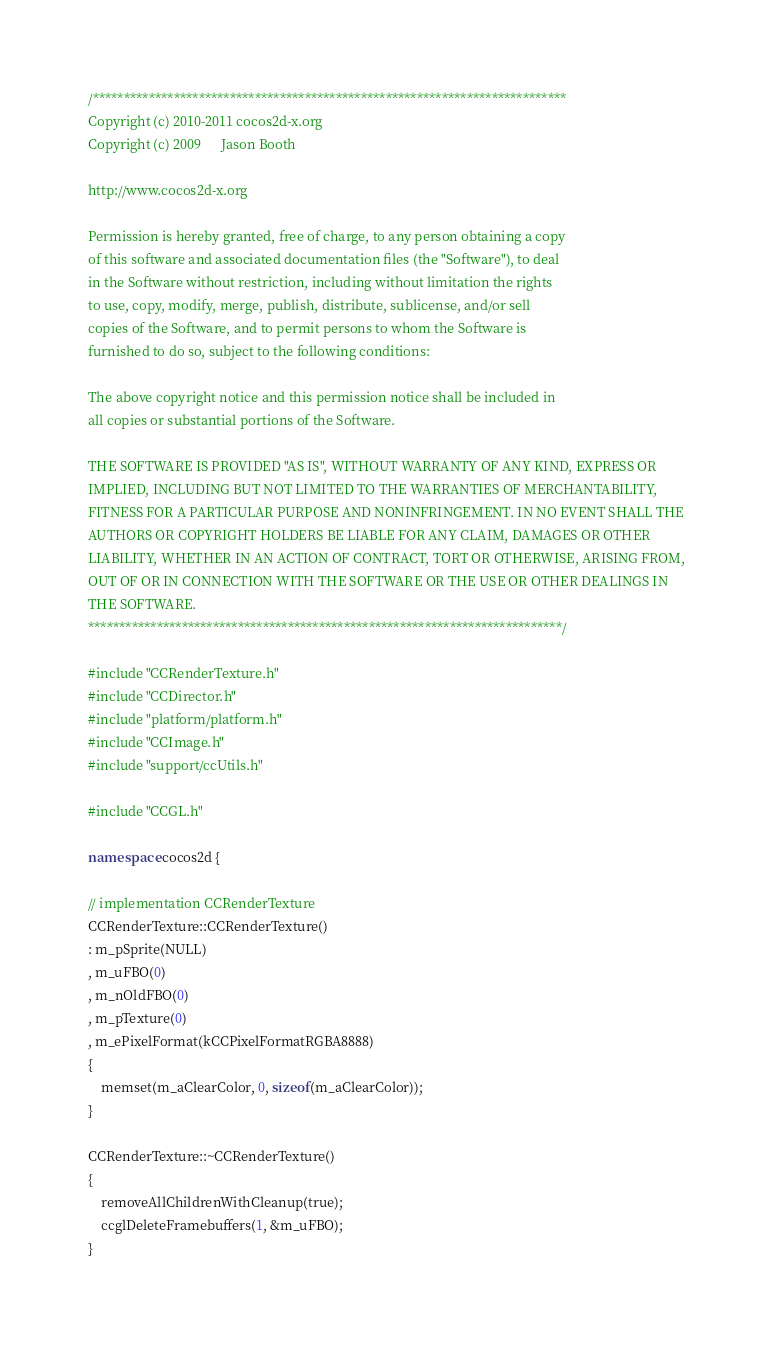Convert code to text. <code><loc_0><loc_0><loc_500><loc_500><_C++_>/****************************************************************************
Copyright (c) 2010-2011 cocos2d-x.org
Copyright (c) 2009      Jason Booth

http://www.cocos2d-x.org

Permission is hereby granted, free of charge, to any person obtaining a copy
of this software and associated documentation files (the "Software"), to deal
in the Software without restriction, including without limitation the rights
to use, copy, modify, merge, publish, distribute, sublicense, and/or sell
copies of the Software, and to permit persons to whom the Software is
furnished to do so, subject to the following conditions:

The above copyright notice and this permission notice shall be included in
all copies or substantial portions of the Software.

THE SOFTWARE IS PROVIDED "AS IS", WITHOUT WARRANTY OF ANY KIND, EXPRESS OR
IMPLIED, INCLUDING BUT NOT LIMITED TO THE WARRANTIES OF MERCHANTABILITY,
FITNESS FOR A PARTICULAR PURPOSE AND NONINFRINGEMENT. IN NO EVENT SHALL THE
AUTHORS OR COPYRIGHT HOLDERS BE LIABLE FOR ANY CLAIM, DAMAGES OR OTHER
LIABILITY, WHETHER IN AN ACTION OF CONTRACT, TORT OR OTHERWISE, ARISING FROM,
OUT OF OR IN CONNECTION WITH THE SOFTWARE OR THE USE OR OTHER DEALINGS IN
THE SOFTWARE.
****************************************************************************/

#include "CCRenderTexture.h"
#include "CCDirector.h"
#include "platform/platform.h"
#include "CCImage.h"
#include "support/ccUtils.h"

#include "CCGL.h"

namespace cocos2d { 

// implementation CCRenderTexture
CCRenderTexture::CCRenderTexture()
: m_pSprite(NULL)
, m_uFBO(0)
, m_nOldFBO(0)
, m_pTexture(0)
, m_ePixelFormat(kCCPixelFormatRGBA8888)
{
    memset(m_aClearColor, 0, sizeof(m_aClearColor));
}

CCRenderTexture::~CCRenderTexture()
{
    removeAllChildrenWithCleanup(true);
    ccglDeleteFramebuffers(1, &m_uFBO);
}
</code> 